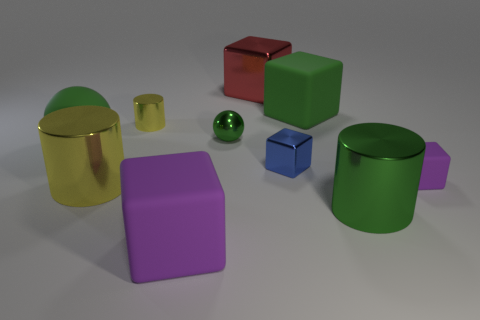What material is the large cylinder left of the big cylinder on the right side of the yellow cylinder behind the large yellow cylinder?
Provide a short and direct response. Metal. Does the big rubber block in front of the tiny metal cylinder have the same color as the tiny rubber cube?
Keep it short and to the point. Yes. What is the material of the small object that is both left of the green shiny cylinder and to the right of the red metallic object?
Offer a very short reply. Metal. Are there any purple things that have the same size as the green rubber sphere?
Provide a succinct answer. Yes. What number of blocks are there?
Offer a terse response. 5. How many purple rubber cubes are to the right of the tiny green object?
Your answer should be compact. 1. Does the big purple block have the same material as the red cube?
Keep it short and to the point. No. How many metallic objects are both behind the tiny green thing and right of the large red metallic cube?
Your answer should be compact. 0. What number of other things are the same color as the large sphere?
Make the answer very short. 3. How many red things are either large matte objects or tiny blocks?
Ensure brevity in your answer.  0. 